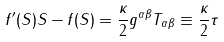Convert formula to latex. <formula><loc_0><loc_0><loc_500><loc_500>f ^ { \prime } ( S ) S - f ( S ) = \frac { \kappa } { 2 } g ^ { \alpha \beta } T _ { \alpha \beta } \equiv \frac { \kappa } { 2 } \tau</formula> 